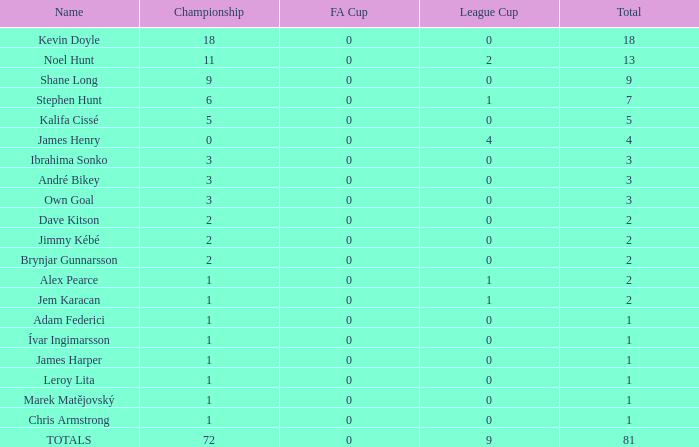How many league cup championships have a total of less than 0? None. 